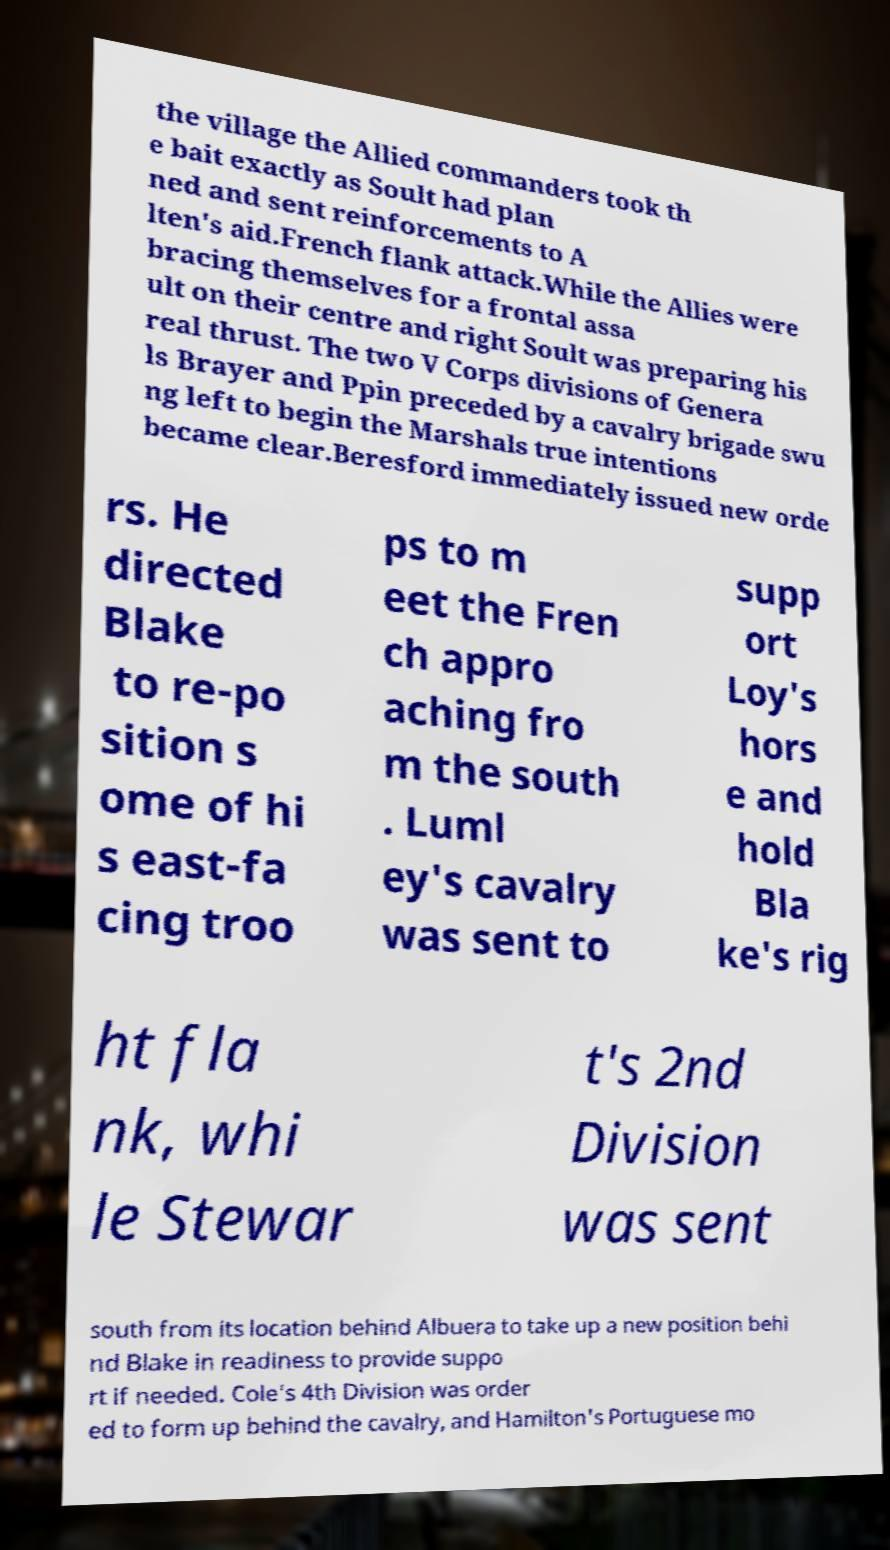Could you assist in decoding the text presented in this image and type it out clearly? the village the Allied commanders took th e bait exactly as Soult had plan ned and sent reinforcements to A lten's aid.French flank attack.While the Allies were bracing themselves for a frontal assa ult on their centre and right Soult was preparing his real thrust. The two V Corps divisions of Genera ls Brayer and Ppin preceded by a cavalry brigade swu ng left to begin the Marshals true intentions became clear.Beresford immediately issued new orde rs. He directed Blake to re-po sition s ome of hi s east-fa cing troo ps to m eet the Fren ch appro aching fro m the south . Luml ey's cavalry was sent to supp ort Loy's hors e and hold Bla ke's rig ht fla nk, whi le Stewar t's 2nd Division was sent south from its location behind Albuera to take up a new position behi nd Blake in readiness to provide suppo rt if needed. Cole's 4th Division was order ed to form up behind the cavalry, and Hamilton's Portuguese mo 